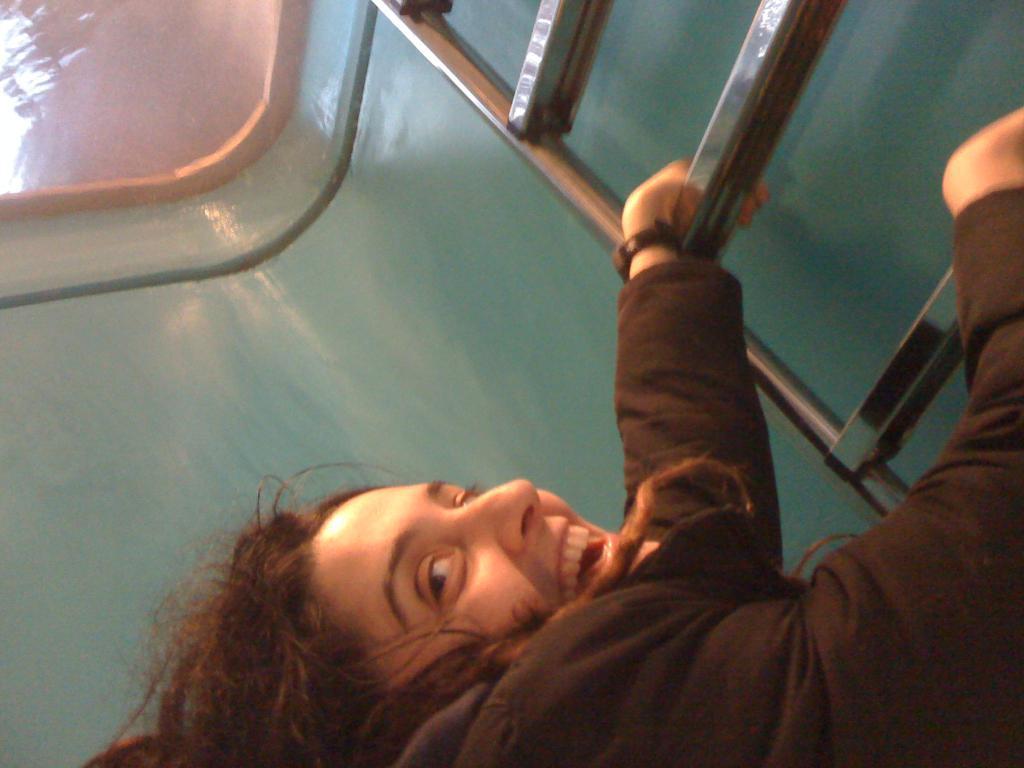Describe this image in one or two sentences. In this image we can see a lady climbing on a ladder. 